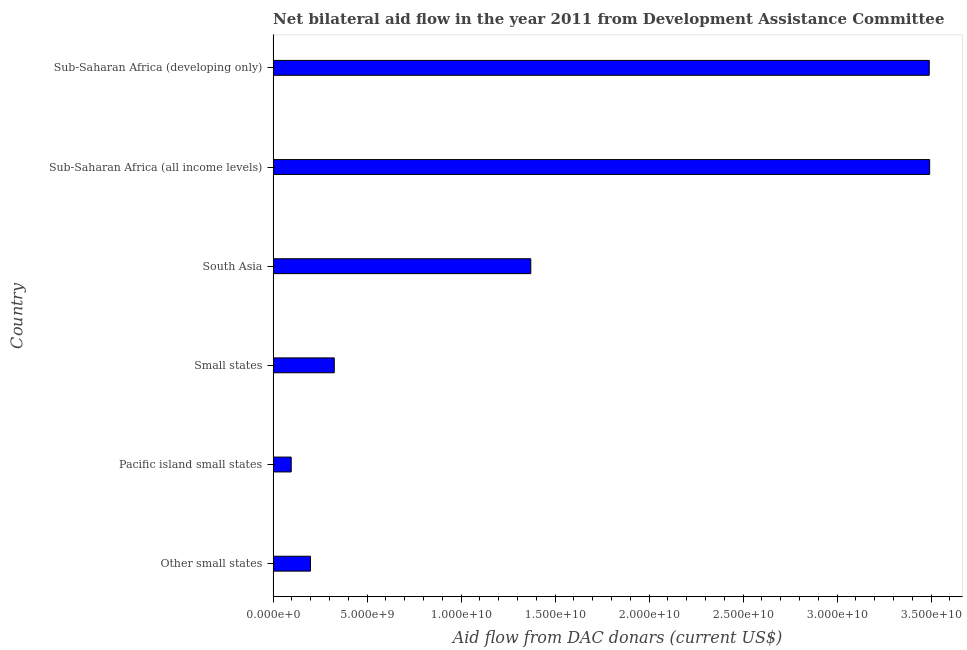Does the graph contain any zero values?
Offer a terse response. No. Does the graph contain grids?
Your answer should be compact. No. What is the title of the graph?
Provide a succinct answer. Net bilateral aid flow in the year 2011 from Development Assistance Committee. What is the label or title of the X-axis?
Offer a very short reply. Aid flow from DAC donars (current US$). What is the label or title of the Y-axis?
Make the answer very short. Country. What is the net bilateral aid flows from dac donors in Other small states?
Offer a very short reply. 1.99e+09. Across all countries, what is the maximum net bilateral aid flows from dac donors?
Provide a short and direct response. 3.49e+1. Across all countries, what is the minimum net bilateral aid flows from dac donors?
Your answer should be compact. 9.62e+08. In which country was the net bilateral aid flows from dac donors maximum?
Provide a short and direct response. Sub-Saharan Africa (all income levels). In which country was the net bilateral aid flows from dac donors minimum?
Your answer should be very brief. Pacific island small states. What is the sum of the net bilateral aid flows from dac donors?
Provide a succinct answer. 8.97e+1. What is the difference between the net bilateral aid flows from dac donors in Sub-Saharan Africa (all income levels) and Sub-Saharan Africa (developing only)?
Provide a succinct answer. 2.18e+07. What is the average net bilateral aid flows from dac donors per country?
Provide a succinct answer. 1.50e+1. What is the median net bilateral aid flows from dac donors?
Your response must be concise. 8.48e+09. What is the ratio of the net bilateral aid flows from dac donors in Pacific island small states to that in Small states?
Offer a terse response. 0.3. Is the difference between the net bilateral aid flows from dac donors in Small states and Sub-Saharan Africa (developing only) greater than the difference between any two countries?
Offer a terse response. No. What is the difference between the highest and the second highest net bilateral aid flows from dac donors?
Provide a succinct answer. 2.18e+07. Is the sum of the net bilateral aid flows from dac donors in Small states and Sub-Saharan Africa (all income levels) greater than the maximum net bilateral aid flows from dac donors across all countries?
Provide a short and direct response. Yes. What is the difference between the highest and the lowest net bilateral aid flows from dac donors?
Provide a short and direct response. 3.40e+1. What is the Aid flow from DAC donars (current US$) in Other small states?
Keep it short and to the point. 1.99e+09. What is the Aid flow from DAC donars (current US$) in Pacific island small states?
Your answer should be compact. 9.62e+08. What is the Aid flow from DAC donars (current US$) in Small states?
Offer a very short reply. 3.25e+09. What is the Aid flow from DAC donars (current US$) of South Asia?
Provide a short and direct response. 1.37e+1. What is the Aid flow from DAC donars (current US$) of Sub-Saharan Africa (all income levels)?
Offer a terse response. 3.49e+1. What is the Aid flow from DAC donars (current US$) of Sub-Saharan Africa (developing only)?
Keep it short and to the point. 3.49e+1. What is the difference between the Aid flow from DAC donars (current US$) in Other small states and Pacific island small states?
Your answer should be compact. 1.02e+09. What is the difference between the Aid flow from DAC donars (current US$) in Other small states and Small states?
Make the answer very short. -1.27e+09. What is the difference between the Aid flow from DAC donars (current US$) in Other small states and South Asia?
Give a very brief answer. -1.17e+1. What is the difference between the Aid flow from DAC donars (current US$) in Other small states and Sub-Saharan Africa (all income levels)?
Provide a succinct answer. -3.29e+1. What is the difference between the Aid flow from DAC donars (current US$) in Other small states and Sub-Saharan Africa (developing only)?
Make the answer very short. -3.29e+1. What is the difference between the Aid flow from DAC donars (current US$) in Pacific island small states and Small states?
Offer a very short reply. -2.29e+09. What is the difference between the Aid flow from DAC donars (current US$) in Pacific island small states and South Asia?
Your answer should be compact. -1.27e+1. What is the difference between the Aid flow from DAC donars (current US$) in Pacific island small states and Sub-Saharan Africa (all income levels)?
Your response must be concise. -3.40e+1. What is the difference between the Aid flow from DAC donars (current US$) in Pacific island small states and Sub-Saharan Africa (developing only)?
Provide a succinct answer. -3.39e+1. What is the difference between the Aid flow from DAC donars (current US$) in Small states and South Asia?
Offer a very short reply. -1.05e+1. What is the difference between the Aid flow from DAC donars (current US$) in Small states and Sub-Saharan Africa (all income levels)?
Your answer should be very brief. -3.17e+1. What is the difference between the Aid flow from DAC donars (current US$) in Small states and Sub-Saharan Africa (developing only)?
Ensure brevity in your answer.  -3.16e+1. What is the difference between the Aid flow from DAC donars (current US$) in South Asia and Sub-Saharan Africa (all income levels)?
Your answer should be compact. -2.12e+1. What is the difference between the Aid flow from DAC donars (current US$) in South Asia and Sub-Saharan Africa (developing only)?
Provide a succinct answer. -2.12e+1. What is the difference between the Aid flow from DAC donars (current US$) in Sub-Saharan Africa (all income levels) and Sub-Saharan Africa (developing only)?
Provide a short and direct response. 2.18e+07. What is the ratio of the Aid flow from DAC donars (current US$) in Other small states to that in Pacific island small states?
Provide a short and direct response. 2.06. What is the ratio of the Aid flow from DAC donars (current US$) in Other small states to that in Small states?
Make the answer very short. 0.61. What is the ratio of the Aid flow from DAC donars (current US$) in Other small states to that in South Asia?
Your answer should be compact. 0.14. What is the ratio of the Aid flow from DAC donars (current US$) in Other small states to that in Sub-Saharan Africa (all income levels)?
Keep it short and to the point. 0.06. What is the ratio of the Aid flow from DAC donars (current US$) in Other small states to that in Sub-Saharan Africa (developing only)?
Provide a short and direct response. 0.06. What is the ratio of the Aid flow from DAC donars (current US$) in Pacific island small states to that in Small states?
Your answer should be compact. 0.3. What is the ratio of the Aid flow from DAC donars (current US$) in Pacific island small states to that in South Asia?
Your response must be concise. 0.07. What is the ratio of the Aid flow from DAC donars (current US$) in Pacific island small states to that in Sub-Saharan Africa (all income levels)?
Ensure brevity in your answer.  0.03. What is the ratio of the Aid flow from DAC donars (current US$) in Pacific island small states to that in Sub-Saharan Africa (developing only)?
Offer a very short reply. 0.03. What is the ratio of the Aid flow from DAC donars (current US$) in Small states to that in South Asia?
Your response must be concise. 0.24. What is the ratio of the Aid flow from DAC donars (current US$) in Small states to that in Sub-Saharan Africa (all income levels)?
Keep it short and to the point. 0.09. What is the ratio of the Aid flow from DAC donars (current US$) in Small states to that in Sub-Saharan Africa (developing only)?
Your answer should be very brief. 0.09. What is the ratio of the Aid flow from DAC donars (current US$) in South Asia to that in Sub-Saharan Africa (all income levels)?
Offer a terse response. 0.39. What is the ratio of the Aid flow from DAC donars (current US$) in South Asia to that in Sub-Saharan Africa (developing only)?
Your answer should be compact. 0.39. 